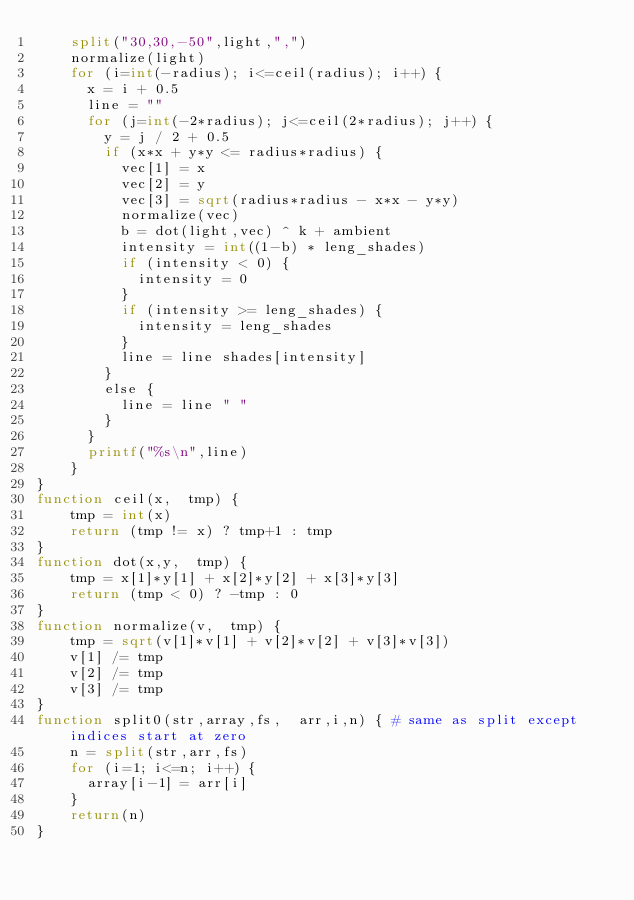<code> <loc_0><loc_0><loc_500><loc_500><_Awk_>    split("30,30,-50",light,",")
    normalize(light)
    for (i=int(-radius); i<=ceil(radius); i++) {
      x = i + 0.5
      line = ""
      for (j=int(-2*radius); j<=ceil(2*radius); j++) {
        y = j / 2 + 0.5
        if (x*x + y*y <= radius*radius) {
          vec[1] = x
          vec[2] = y
          vec[3] = sqrt(radius*radius - x*x - y*y)
          normalize(vec)
          b = dot(light,vec) ^ k + ambient
          intensity = int((1-b) * leng_shades)
          if (intensity < 0) {
            intensity = 0
          }
          if (intensity >= leng_shades) {
            intensity = leng_shades
          }
          line = line shades[intensity]
        }
        else {
          line = line " "
        }
      }
      printf("%s\n",line)
    }
}
function ceil(x,  tmp) {
    tmp = int(x)
    return (tmp != x) ? tmp+1 : tmp
}
function dot(x,y,  tmp) {
    tmp = x[1]*y[1] + x[2]*y[2] + x[3]*y[3]
    return (tmp < 0) ? -tmp : 0
}
function normalize(v,  tmp) {
    tmp = sqrt(v[1]*v[1] + v[2]*v[2] + v[3]*v[3])
    v[1] /= tmp
    v[2] /= tmp
    v[3] /= tmp
}
function split0(str,array,fs,  arr,i,n) { # same as split except indices start at zero
    n = split(str,arr,fs)
    for (i=1; i<=n; i++) {
      array[i-1] = arr[i]
    }
    return(n)
}
</code> 